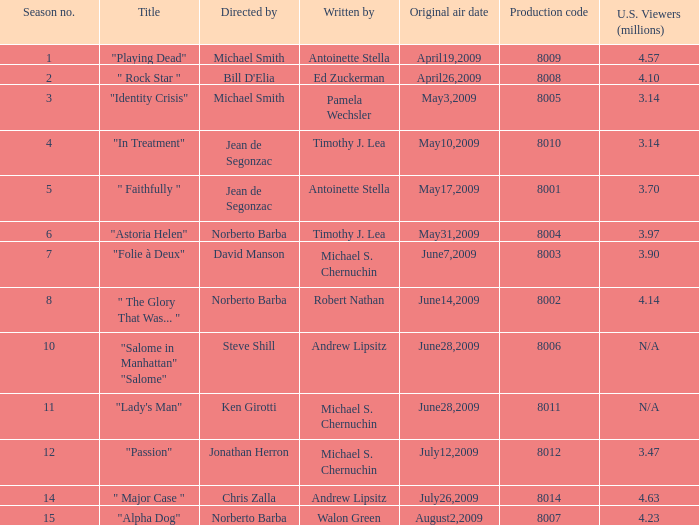What is the name of the episode whose writer is timothy j. lea and the director is norberto barba? "Astoria Helen". 